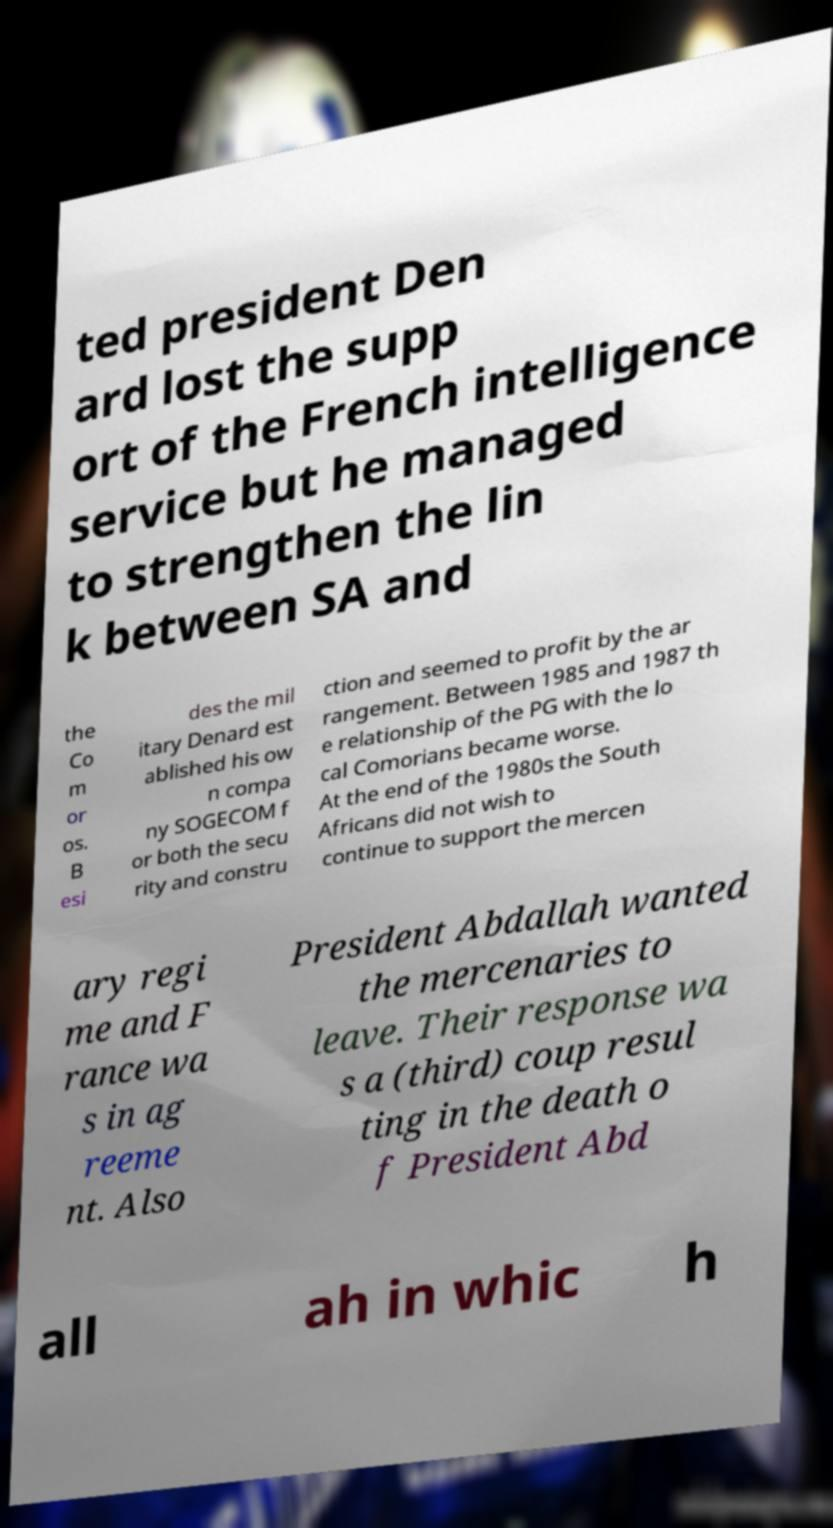There's text embedded in this image that I need extracted. Can you transcribe it verbatim? ted president Den ard lost the supp ort of the French intelligence service but he managed to strengthen the lin k between SA and the Co m or os. B esi des the mil itary Denard est ablished his ow n compa ny SOGECOM f or both the secu rity and constru ction and seemed to profit by the ar rangement. Between 1985 and 1987 th e relationship of the PG with the lo cal Comorians became worse. At the end of the 1980s the South Africans did not wish to continue to support the mercen ary regi me and F rance wa s in ag reeme nt. Also President Abdallah wanted the mercenaries to leave. Their response wa s a (third) coup resul ting in the death o f President Abd all ah in whic h 